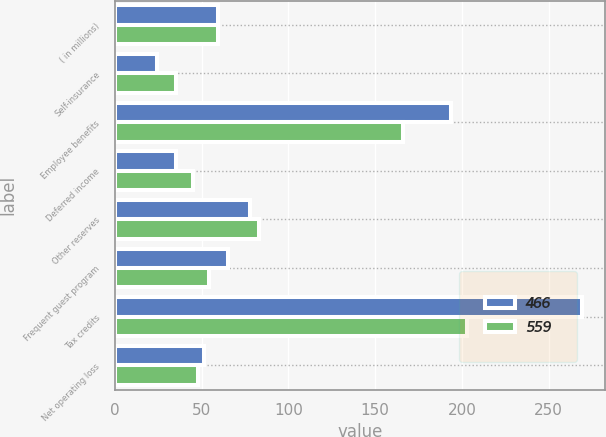Convert chart. <chart><loc_0><loc_0><loc_500><loc_500><stacked_bar_chart><ecel><fcel>( in millions)<fcel>Self-insurance<fcel>Employee benefits<fcel>Deferred income<fcel>Other reserves<fcel>Frequent guest program<fcel>Tax credits<fcel>Net operating loss<nl><fcel>466<fcel>59.5<fcel>24<fcel>194<fcel>35<fcel>78<fcel>65<fcel>269<fcel>51<nl><fcel>559<fcel>59.5<fcel>35<fcel>166<fcel>45<fcel>83<fcel>54<fcel>203<fcel>48<nl></chart> 